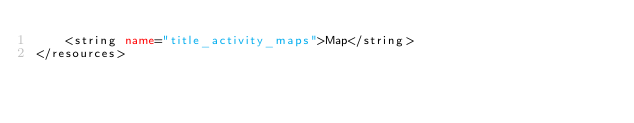<code> <loc_0><loc_0><loc_500><loc_500><_XML_>    <string name="title_activity_maps">Map</string>
</resources>
</code> 